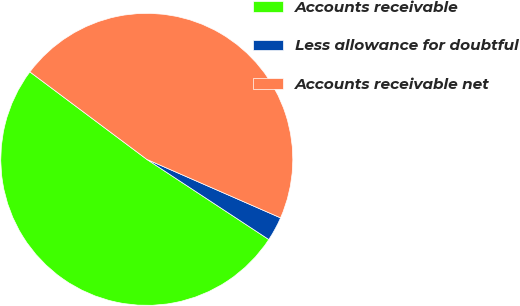Convert chart to OTSL. <chart><loc_0><loc_0><loc_500><loc_500><pie_chart><fcel>Accounts receivable<fcel>Less allowance for doubtful<fcel>Accounts receivable net<nl><fcel>50.97%<fcel>2.69%<fcel>46.34%<nl></chart> 